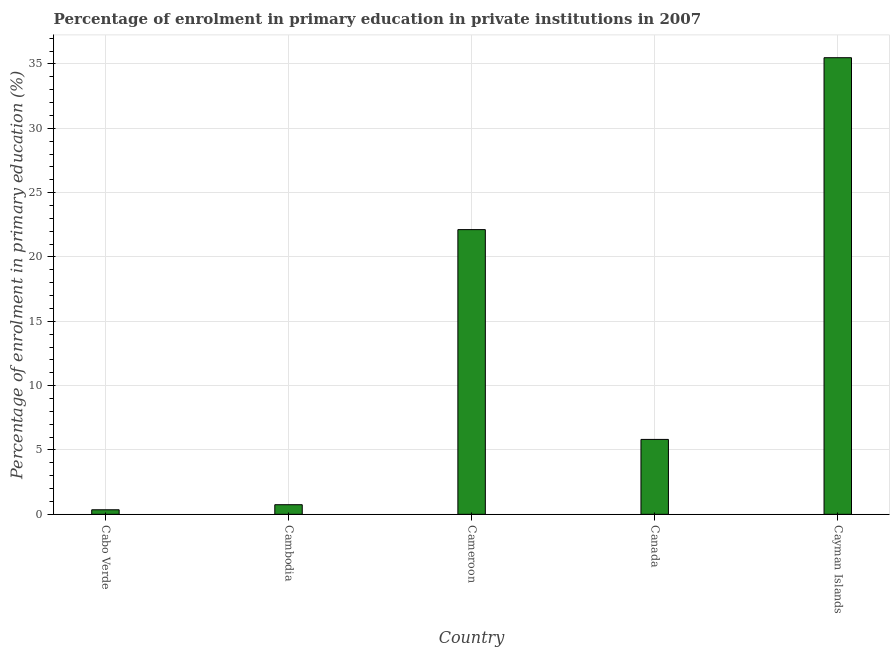Does the graph contain grids?
Offer a very short reply. Yes. What is the title of the graph?
Make the answer very short. Percentage of enrolment in primary education in private institutions in 2007. What is the label or title of the Y-axis?
Provide a succinct answer. Percentage of enrolment in primary education (%). What is the enrolment percentage in primary education in Cayman Islands?
Your response must be concise. 35.48. Across all countries, what is the maximum enrolment percentage in primary education?
Provide a short and direct response. 35.48. Across all countries, what is the minimum enrolment percentage in primary education?
Your response must be concise. 0.35. In which country was the enrolment percentage in primary education maximum?
Offer a terse response. Cayman Islands. In which country was the enrolment percentage in primary education minimum?
Your response must be concise. Cabo Verde. What is the sum of the enrolment percentage in primary education?
Offer a very short reply. 64.53. What is the difference between the enrolment percentage in primary education in Cabo Verde and Cambodia?
Keep it short and to the point. -0.39. What is the average enrolment percentage in primary education per country?
Offer a very short reply. 12.9. What is the median enrolment percentage in primary education?
Make the answer very short. 5.82. What is the ratio of the enrolment percentage in primary education in Cambodia to that in Canada?
Offer a very short reply. 0.13. Is the enrolment percentage in primary education in Canada less than that in Cayman Islands?
Offer a very short reply. Yes. Is the difference between the enrolment percentage in primary education in Cabo Verde and Canada greater than the difference between any two countries?
Provide a short and direct response. No. What is the difference between the highest and the second highest enrolment percentage in primary education?
Ensure brevity in your answer.  13.36. Is the sum of the enrolment percentage in primary education in Cameroon and Cayman Islands greater than the maximum enrolment percentage in primary education across all countries?
Make the answer very short. Yes. What is the difference between the highest and the lowest enrolment percentage in primary education?
Provide a short and direct response. 35.13. How many countries are there in the graph?
Your response must be concise. 5. What is the difference between two consecutive major ticks on the Y-axis?
Offer a terse response. 5. What is the Percentage of enrolment in primary education (%) in Cabo Verde?
Offer a terse response. 0.35. What is the Percentage of enrolment in primary education (%) in Cambodia?
Provide a succinct answer. 0.75. What is the Percentage of enrolment in primary education (%) in Cameroon?
Your answer should be very brief. 22.12. What is the Percentage of enrolment in primary education (%) in Canada?
Provide a short and direct response. 5.82. What is the Percentage of enrolment in primary education (%) in Cayman Islands?
Make the answer very short. 35.48. What is the difference between the Percentage of enrolment in primary education (%) in Cabo Verde and Cambodia?
Provide a succinct answer. -0.39. What is the difference between the Percentage of enrolment in primary education (%) in Cabo Verde and Cameroon?
Offer a terse response. -21.77. What is the difference between the Percentage of enrolment in primary education (%) in Cabo Verde and Canada?
Your answer should be very brief. -5.47. What is the difference between the Percentage of enrolment in primary education (%) in Cabo Verde and Cayman Islands?
Provide a succinct answer. -35.13. What is the difference between the Percentage of enrolment in primary education (%) in Cambodia and Cameroon?
Give a very brief answer. -21.38. What is the difference between the Percentage of enrolment in primary education (%) in Cambodia and Canada?
Your answer should be compact. -5.07. What is the difference between the Percentage of enrolment in primary education (%) in Cambodia and Cayman Islands?
Give a very brief answer. -34.74. What is the difference between the Percentage of enrolment in primary education (%) in Cameroon and Canada?
Provide a succinct answer. 16.3. What is the difference between the Percentage of enrolment in primary education (%) in Cameroon and Cayman Islands?
Offer a very short reply. -13.36. What is the difference between the Percentage of enrolment in primary education (%) in Canada and Cayman Islands?
Provide a short and direct response. -29.66. What is the ratio of the Percentage of enrolment in primary education (%) in Cabo Verde to that in Cambodia?
Offer a terse response. 0.47. What is the ratio of the Percentage of enrolment in primary education (%) in Cabo Verde to that in Cameroon?
Ensure brevity in your answer.  0.02. What is the ratio of the Percentage of enrolment in primary education (%) in Cabo Verde to that in Canada?
Give a very brief answer. 0.06. What is the ratio of the Percentage of enrolment in primary education (%) in Cabo Verde to that in Cayman Islands?
Make the answer very short. 0.01. What is the ratio of the Percentage of enrolment in primary education (%) in Cambodia to that in Cameroon?
Make the answer very short. 0.03. What is the ratio of the Percentage of enrolment in primary education (%) in Cambodia to that in Canada?
Your answer should be very brief. 0.13. What is the ratio of the Percentage of enrolment in primary education (%) in Cambodia to that in Cayman Islands?
Offer a very short reply. 0.02. What is the ratio of the Percentage of enrolment in primary education (%) in Cameroon to that in Canada?
Offer a terse response. 3.8. What is the ratio of the Percentage of enrolment in primary education (%) in Cameroon to that in Cayman Islands?
Your response must be concise. 0.62. What is the ratio of the Percentage of enrolment in primary education (%) in Canada to that in Cayman Islands?
Offer a terse response. 0.16. 